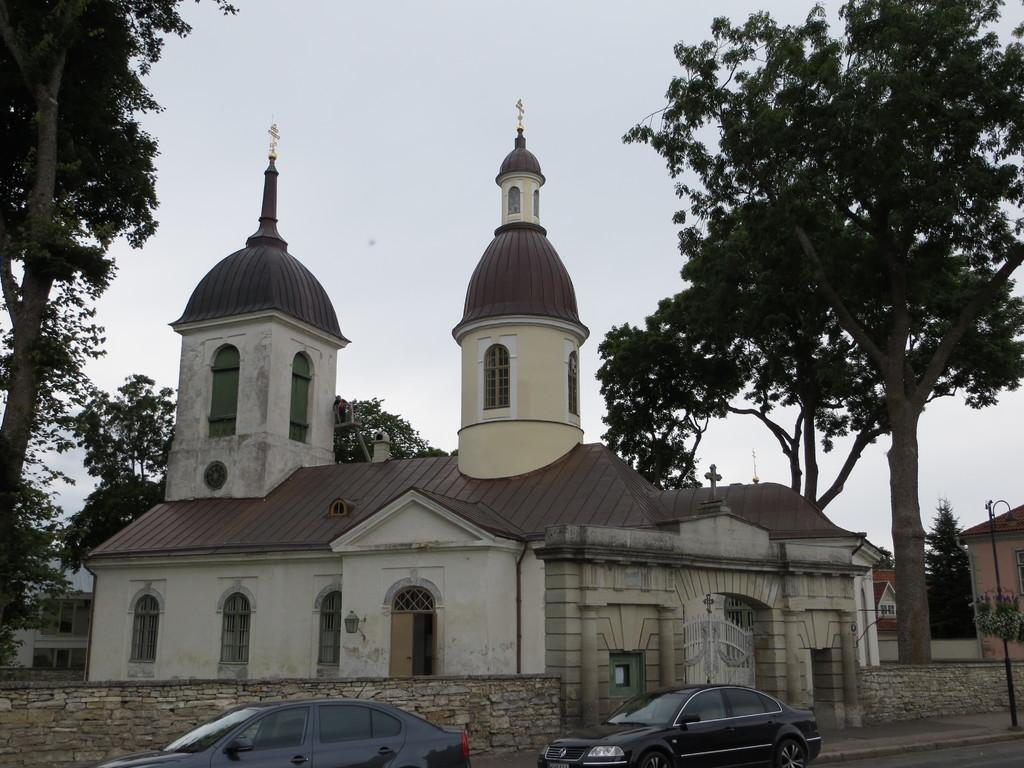What can be seen in the image? There are vehicles in the image. What is visible in the background of the image? There are buildings and trees in the background of the image. What colors are the buildings and trees? The buildings are in white and brown colors, and the trees are in green color. What is the color of the sky in the image? The sky is in white color. What type of work are the legs doing in the image? There are no legs visible in the image; it features vehicles, buildings, trees, and the sky. 